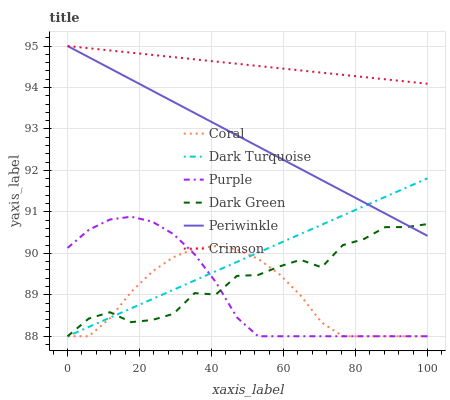Does Coral have the minimum area under the curve?
Answer yes or no. Yes. Does Crimson have the maximum area under the curve?
Answer yes or no. Yes. Does Dark Turquoise have the minimum area under the curve?
Answer yes or no. No. Does Dark Turquoise have the maximum area under the curve?
Answer yes or no. No. Is Crimson the smoothest?
Answer yes or no. Yes. Is Dark Green the roughest?
Answer yes or no. Yes. Is Dark Turquoise the smoothest?
Answer yes or no. No. Is Dark Turquoise the roughest?
Answer yes or no. No. Does Periwinkle have the lowest value?
Answer yes or no. No. Does Crimson have the highest value?
Answer yes or no. Yes. Does Dark Turquoise have the highest value?
Answer yes or no. No. Is Coral less than Periwinkle?
Answer yes or no. Yes. Is Crimson greater than Dark Green?
Answer yes or no. Yes. Does Periwinkle intersect Crimson?
Answer yes or no. Yes. Is Periwinkle less than Crimson?
Answer yes or no. No. Is Periwinkle greater than Crimson?
Answer yes or no. No. Does Coral intersect Periwinkle?
Answer yes or no. No. 